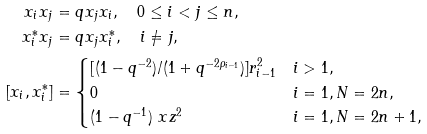Convert formula to latex. <formula><loc_0><loc_0><loc_500><loc_500>x _ { i } x _ { j } & = q x _ { j } x _ { i } , \quad 0 \leq i < j \leq n , \\ x _ { i } ^ { * } x _ { j } & = q x _ { j } x _ { i } ^ { * } , \quad i \neq j , \\ [ x _ { i } , x _ { i } ^ { * } ] & = \begin{cases} [ ( 1 - q ^ { - 2 } ) / ( 1 + q ^ { - 2 \rho _ { i - 1 } } ) ] r ^ { 2 } _ { i - 1 } & i > 1 , \\ 0 & i = 1 , N = 2 n , \\ ( 1 - q ^ { - 1 } ) \ x z ^ { 2 } & i = 1 , N = 2 n + 1 , \end{cases}</formula> 